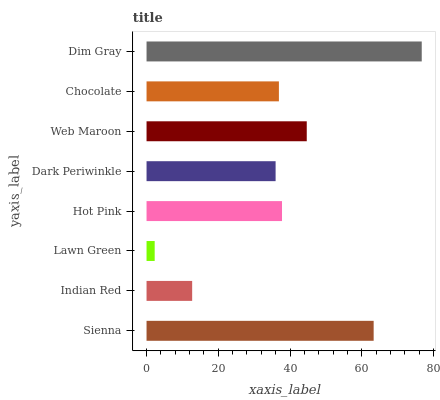Is Lawn Green the minimum?
Answer yes or no. Yes. Is Dim Gray the maximum?
Answer yes or no. Yes. Is Indian Red the minimum?
Answer yes or no. No. Is Indian Red the maximum?
Answer yes or no. No. Is Sienna greater than Indian Red?
Answer yes or no. Yes. Is Indian Red less than Sienna?
Answer yes or no. Yes. Is Indian Red greater than Sienna?
Answer yes or no. No. Is Sienna less than Indian Red?
Answer yes or no. No. Is Hot Pink the high median?
Answer yes or no. Yes. Is Chocolate the low median?
Answer yes or no. Yes. Is Chocolate the high median?
Answer yes or no. No. Is Dark Periwinkle the low median?
Answer yes or no. No. 